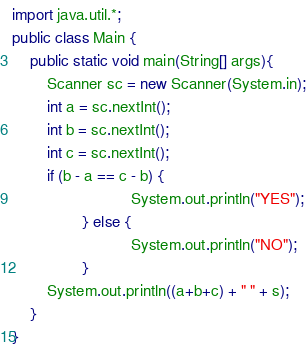<code> <loc_0><loc_0><loc_500><loc_500><_Java_>import java.util.*;
public class Main {
	public static void main(String[] args){
		Scanner sc = new Scanner(System.in);
		int a = sc.nextInt();
		int b = sc.nextInt();
		int c = sc.nextInt();
		if (b - a == c - b) {
                           System.out.println("YES");
                } else {
                           System.out.println("NO");
                }
		System.out.println((a+b+c) + " " + s);
	}
}</code> 